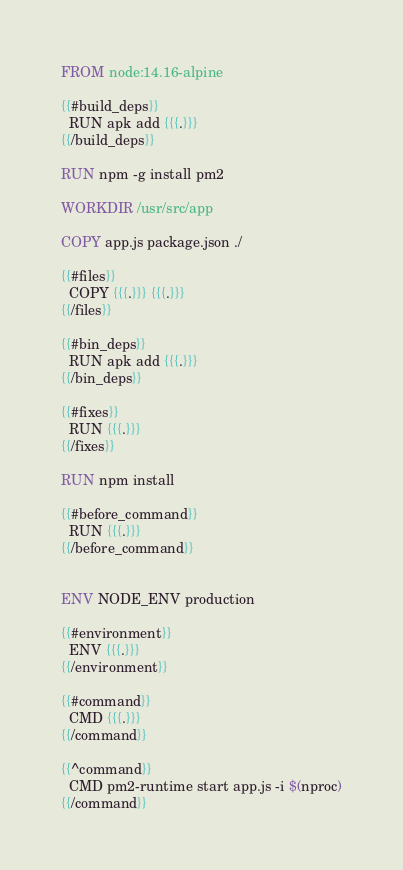<code> <loc_0><loc_0><loc_500><loc_500><_Dockerfile_>FROM node:14.16-alpine

{{#build_deps}}
  RUN apk add {{{.}}}
{{/build_deps}}

RUN npm -g install pm2

WORKDIR /usr/src/app

COPY app.js package.json ./

{{#files}}
  COPY {{{.}}} {{{.}}}
{{/files}}

{{#bin_deps}}
  RUN apk add {{{.}}}
{{/bin_deps}}

{{#fixes}}
  RUN {{{.}}}
{{/fixes}}

RUN npm install

{{#before_command}}
  RUN {{{.}}}
{{/before_command}}


ENV NODE_ENV production

{{#environment}}
  ENV {{{.}}}
{{/environment}}

{{#command}}
  CMD {{{.}}}
{{/command}}

{{^command}}
  CMD pm2-runtime start app.js -i $(nproc)
{{/command}}
</code> 